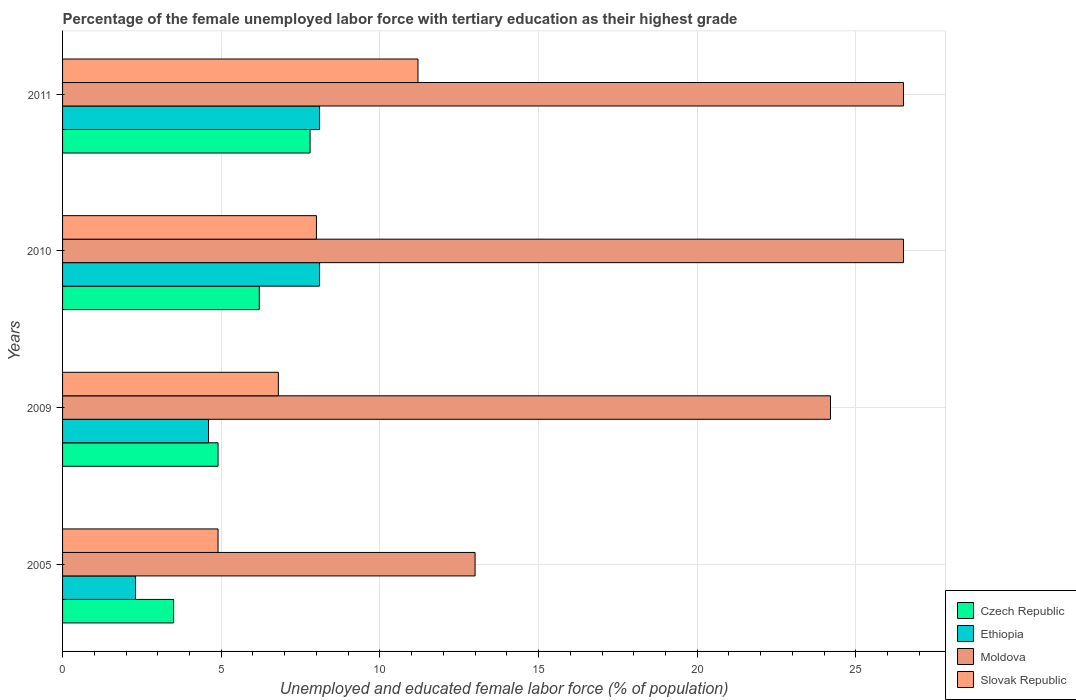How many different coloured bars are there?
Your answer should be compact. 4. Are the number of bars per tick equal to the number of legend labels?
Keep it short and to the point. Yes. How many bars are there on the 1st tick from the bottom?
Offer a very short reply. 4. What is the label of the 4th group of bars from the top?
Provide a succinct answer. 2005. In how many cases, is the number of bars for a given year not equal to the number of legend labels?
Your answer should be very brief. 0. What is the percentage of the unemployed female labor force with tertiary education in Czech Republic in 2009?
Your response must be concise. 4.9. Across all years, what is the maximum percentage of the unemployed female labor force with tertiary education in Slovak Republic?
Provide a short and direct response. 11.2. Across all years, what is the minimum percentage of the unemployed female labor force with tertiary education in Slovak Republic?
Your answer should be very brief. 4.9. In which year was the percentage of the unemployed female labor force with tertiary education in Slovak Republic maximum?
Your answer should be very brief. 2011. In which year was the percentage of the unemployed female labor force with tertiary education in Moldova minimum?
Keep it short and to the point. 2005. What is the total percentage of the unemployed female labor force with tertiary education in Ethiopia in the graph?
Offer a terse response. 23.1. What is the difference between the percentage of the unemployed female labor force with tertiary education in Slovak Republic in 2009 and that in 2010?
Offer a very short reply. -1.2. What is the difference between the percentage of the unemployed female labor force with tertiary education in Czech Republic in 2009 and the percentage of the unemployed female labor force with tertiary education in Slovak Republic in 2011?
Give a very brief answer. -6.3. What is the average percentage of the unemployed female labor force with tertiary education in Moldova per year?
Your answer should be compact. 22.55. In the year 2005, what is the difference between the percentage of the unemployed female labor force with tertiary education in Ethiopia and percentage of the unemployed female labor force with tertiary education in Czech Republic?
Your answer should be compact. -1.2. In how many years, is the percentage of the unemployed female labor force with tertiary education in Czech Republic greater than 21 %?
Your response must be concise. 0. What is the ratio of the percentage of the unemployed female labor force with tertiary education in Czech Republic in 2009 to that in 2010?
Make the answer very short. 0.79. Is the percentage of the unemployed female labor force with tertiary education in Moldova in 2009 less than that in 2011?
Your response must be concise. Yes. Is the difference between the percentage of the unemployed female labor force with tertiary education in Ethiopia in 2009 and 2011 greater than the difference between the percentage of the unemployed female labor force with tertiary education in Czech Republic in 2009 and 2011?
Offer a terse response. No. What is the difference between the highest and the second highest percentage of the unemployed female labor force with tertiary education in Slovak Republic?
Offer a terse response. 3.2. In how many years, is the percentage of the unemployed female labor force with tertiary education in Slovak Republic greater than the average percentage of the unemployed female labor force with tertiary education in Slovak Republic taken over all years?
Ensure brevity in your answer.  2. Is the sum of the percentage of the unemployed female labor force with tertiary education in Moldova in 2005 and 2010 greater than the maximum percentage of the unemployed female labor force with tertiary education in Czech Republic across all years?
Give a very brief answer. Yes. What does the 4th bar from the top in 2009 represents?
Provide a short and direct response. Czech Republic. What does the 3rd bar from the bottom in 2005 represents?
Make the answer very short. Moldova. Is it the case that in every year, the sum of the percentage of the unemployed female labor force with tertiary education in Czech Republic and percentage of the unemployed female labor force with tertiary education in Moldova is greater than the percentage of the unemployed female labor force with tertiary education in Ethiopia?
Keep it short and to the point. Yes. Are all the bars in the graph horizontal?
Ensure brevity in your answer.  Yes. How many years are there in the graph?
Keep it short and to the point. 4. What is the difference between two consecutive major ticks on the X-axis?
Your response must be concise. 5. Does the graph contain any zero values?
Provide a short and direct response. No. Where does the legend appear in the graph?
Give a very brief answer. Bottom right. How many legend labels are there?
Your response must be concise. 4. What is the title of the graph?
Give a very brief answer. Percentage of the female unemployed labor force with tertiary education as their highest grade. Does "Palau" appear as one of the legend labels in the graph?
Make the answer very short. No. What is the label or title of the X-axis?
Ensure brevity in your answer.  Unemployed and educated female labor force (% of population). What is the label or title of the Y-axis?
Your response must be concise. Years. What is the Unemployed and educated female labor force (% of population) of Czech Republic in 2005?
Provide a succinct answer. 3.5. What is the Unemployed and educated female labor force (% of population) in Ethiopia in 2005?
Your response must be concise. 2.3. What is the Unemployed and educated female labor force (% of population) of Slovak Republic in 2005?
Your answer should be very brief. 4.9. What is the Unemployed and educated female labor force (% of population) of Czech Republic in 2009?
Your answer should be very brief. 4.9. What is the Unemployed and educated female labor force (% of population) of Ethiopia in 2009?
Give a very brief answer. 4.6. What is the Unemployed and educated female labor force (% of population) of Moldova in 2009?
Provide a short and direct response. 24.2. What is the Unemployed and educated female labor force (% of population) in Slovak Republic in 2009?
Offer a terse response. 6.8. What is the Unemployed and educated female labor force (% of population) in Czech Republic in 2010?
Provide a short and direct response. 6.2. What is the Unemployed and educated female labor force (% of population) in Ethiopia in 2010?
Your answer should be compact. 8.1. What is the Unemployed and educated female labor force (% of population) in Moldova in 2010?
Provide a succinct answer. 26.5. What is the Unemployed and educated female labor force (% of population) of Slovak Republic in 2010?
Offer a very short reply. 8. What is the Unemployed and educated female labor force (% of population) in Czech Republic in 2011?
Your response must be concise. 7.8. What is the Unemployed and educated female labor force (% of population) of Ethiopia in 2011?
Make the answer very short. 8.1. What is the Unemployed and educated female labor force (% of population) in Moldova in 2011?
Ensure brevity in your answer.  26.5. What is the Unemployed and educated female labor force (% of population) in Slovak Republic in 2011?
Your answer should be compact. 11.2. Across all years, what is the maximum Unemployed and educated female labor force (% of population) of Czech Republic?
Provide a short and direct response. 7.8. Across all years, what is the maximum Unemployed and educated female labor force (% of population) of Ethiopia?
Keep it short and to the point. 8.1. Across all years, what is the maximum Unemployed and educated female labor force (% of population) of Slovak Republic?
Your response must be concise. 11.2. Across all years, what is the minimum Unemployed and educated female labor force (% of population) of Czech Republic?
Keep it short and to the point. 3.5. Across all years, what is the minimum Unemployed and educated female labor force (% of population) in Ethiopia?
Keep it short and to the point. 2.3. Across all years, what is the minimum Unemployed and educated female labor force (% of population) in Slovak Republic?
Ensure brevity in your answer.  4.9. What is the total Unemployed and educated female labor force (% of population) in Czech Republic in the graph?
Make the answer very short. 22.4. What is the total Unemployed and educated female labor force (% of population) in Ethiopia in the graph?
Make the answer very short. 23.1. What is the total Unemployed and educated female labor force (% of population) of Moldova in the graph?
Ensure brevity in your answer.  90.2. What is the total Unemployed and educated female labor force (% of population) of Slovak Republic in the graph?
Your response must be concise. 30.9. What is the difference between the Unemployed and educated female labor force (% of population) of Czech Republic in 2005 and that in 2009?
Offer a very short reply. -1.4. What is the difference between the Unemployed and educated female labor force (% of population) in Ethiopia in 2005 and that in 2009?
Your response must be concise. -2.3. What is the difference between the Unemployed and educated female labor force (% of population) in Slovak Republic in 2005 and that in 2009?
Your answer should be very brief. -1.9. What is the difference between the Unemployed and educated female labor force (% of population) of Slovak Republic in 2005 and that in 2010?
Make the answer very short. -3.1. What is the difference between the Unemployed and educated female labor force (% of population) of Czech Republic in 2005 and that in 2011?
Offer a terse response. -4.3. What is the difference between the Unemployed and educated female labor force (% of population) of Moldova in 2005 and that in 2011?
Keep it short and to the point. -13.5. What is the difference between the Unemployed and educated female labor force (% of population) of Slovak Republic in 2005 and that in 2011?
Your response must be concise. -6.3. What is the difference between the Unemployed and educated female labor force (% of population) of Czech Republic in 2009 and that in 2010?
Keep it short and to the point. -1.3. What is the difference between the Unemployed and educated female labor force (% of population) in Ethiopia in 2009 and that in 2010?
Offer a very short reply. -3.5. What is the difference between the Unemployed and educated female labor force (% of population) in Slovak Republic in 2009 and that in 2010?
Provide a short and direct response. -1.2. What is the difference between the Unemployed and educated female labor force (% of population) in Moldova in 2009 and that in 2011?
Offer a terse response. -2.3. What is the difference between the Unemployed and educated female labor force (% of population) of Ethiopia in 2010 and that in 2011?
Keep it short and to the point. 0. What is the difference between the Unemployed and educated female labor force (% of population) in Czech Republic in 2005 and the Unemployed and educated female labor force (% of population) in Ethiopia in 2009?
Ensure brevity in your answer.  -1.1. What is the difference between the Unemployed and educated female labor force (% of population) of Czech Republic in 2005 and the Unemployed and educated female labor force (% of population) of Moldova in 2009?
Your answer should be compact. -20.7. What is the difference between the Unemployed and educated female labor force (% of population) in Czech Republic in 2005 and the Unemployed and educated female labor force (% of population) in Slovak Republic in 2009?
Offer a very short reply. -3.3. What is the difference between the Unemployed and educated female labor force (% of population) in Ethiopia in 2005 and the Unemployed and educated female labor force (% of population) in Moldova in 2009?
Make the answer very short. -21.9. What is the difference between the Unemployed and educated female labor force (% of population) in Ethiopia in 2005 and the Unemployed and educated female labor force (% of population) in Slovak Republic in 2009?
Offer a terse response. -4.5. What is the difference between the Unemployed and educated female labor force (% of population) in Czech Republic in 2005 and the Unemployed and educated female labor force (% of population) in Ethiopia in 2010?
Offer a terse response. -4.6. What is the difference between the Unemployed and educated female labor force (% of population) of Czech Republic in 2005 and the Unemployed and educated female labor force (% of population) of Moldova in 2010?
Give a very brief answer. -23. What is the difference between the Unemployed and educated female labor force (% of population) of Czech Republic in 2005 and the Unemployed and educated female labor force (% of population) of Slovak Republic in 2010?
Your response must be concise. -4.5. What is the difference between the Unemployed and educated female labor force (% of population) of Ethiopia in 2005 and the Unemployed and educated female labor force (% of population) of Moldova in 2010?
Make the answer very short. -24.2. What is the difference between the Unemployed and educated female labor force (% of population) in Czech Republic in 2005 and the Unemployed and educated female labor force (% of population) in Ethiopia in 2011?
Give a very brief answer. -4.6. What is the difference between the Unemployed and educated female labor force (% of population) in Czech Republic in 2005 and the Unemployed and educated female labor force (% of population) in Moldova in 2011?
Your answer should be compact. -23. What is the difference between the Unemployed and educated female labor force (% of population) of Czech Republic in 2005 and the Unemployed and educated female labor force (% of population) of Slovak Republic in 2011?
Your answer should be very brief. -7.7. What is the difference between the Unemployed and educated female labor force (% of population) in Ethiopia in 2005 and the Unemployed and educated female labor force (% of population) in Moldova in 2011?
Your response must be concise. -24.2. What is the difference between the Unemployed and educated female labor force (% of population) in Moldova in 2005 and the Unemployed and educated female labor force (% of population) in Slovak Republic in 2011?
Keep it short and to the point. 1.8. What is the difference between the Unemployed and educated female labor force (% of population) of Czech Republic in 2009 and the Unemployed and educated female labor force (% of population) of Ethiopia in 2010?
Your answer should be very brief. -3.2. What is the difference between the Unemployed and educated female labor force (% of population) of Czech Republic in 2009 and the Unemployed and educated female labor force (% of population) of Moldova in 2010?
Offer a terse response. -21.6. What is the difference between the Unemployed and educated female labor force (% of population) of Ethiopia in 2009 and the Unemployed and educated female labor force (% of population) of Moldova in 2010?
Keep it short and to the point. -21.9. What is the difference between the Unemployed and educated female labor force (% of population) in Ethiopia in 2009 and the Unemployed and educated female labor force (% of population) in Slovak Republic in 2010?
Provide a short and direct response. -3.4. What is the difference between the Unemployed and educated female labor force (% of population) in Moldova in 2009 and the Unemployed and educated female labor force (% of population) in Slovak Republic in 2010?
Your answer should be very brief. 16.2. What is the difference between the Unemployed and educated female labor force (% of population) in Czech Republic in 2009 and the Unemployed and educated female labor force (% of population) in Moldova in 2011?
Offer a terse response. -21.6. What is the difference between the Unemployed and educated female labor force (% of population) of Czech Republic in 2009 and the Unemployed and educated female labor force (% of population) of Slovak Republic in 2011?
Offer a terse response. -6.3. What is the difference between the Unemployed and educated female labor force (% of population) in Ethiopia in 2009 and the Unemployed and educated female labor force (% of population) in Moldova in 2011?
Your answer should be compact. -21.9. What is the difference between the Unemployed and educated female labor force (% of population) of Czech Republic in 2010 and the Unemployed and educated female labor force (% of population) of Ethiopia in 2011?
Offer a very short reply. -1.9. What is the difference between the Unemployed and educated female labor force (% of population) in Czech Republic in 2010 and the Unemployed and educated female labor force (% of population) in Moldova in 2011?
Give a very brief answer. -20.3. What is the difference between the Unemployed and educated female labor force (% of population) of Czech Republic in 2010 and the Unemployed and educated female labor force (% of population) of Slovak Republic in 2011?
Ensure brevity in your answer.  -5. What is the difference between the Unemployed and educated female labor force (% of population) of Ethiopia in 2010 and the Unemployed and educated female labor force (% of population) of Moldova in 2011?
Your response must be concise. -18.4. What is the difference between the Unemployed and educated female labor force (% of population) in Ethiopia in 2010 and the Unemployed and educated female labor force (% of population) in Slovak Republic in 2011?
Your answer should be compact. -3.1. What is the average Unemployed and educated female labor force (% of population) in Ethiopia per year?
Offer a very short reply. 5.78. What is the average Unemployed and educated female labor force (% of population) in Moldova per year?
Your answer should be compact. 22.55. What is the average Unemployed and educated female labor force (% of population) of Slovak Republic per year?
Offer a very short reply. 7.72. In the year 2005, what is the difference between the Unemployed and educated female labor force (% of population) of Czech Republic and Unemployed and educated female labor force (% of population) of Ethiopia?
Your answer should be compact. 1.2. In the year 2005, what is the difference between the Unemployed and educated female labor force (% of population) of Czech Republic and Unemployed and educated female labor force (% of population) of Moldova?
Keep it short and to the point. -9.5. In the year 2005, what is the difference between the Unemployed and educated female labor force (% of population) of Czech Republic and Unemployed and educated female labor force (% of population) of Slovak Republic?
Provide a short and direct response. -1.4. In the year 2005, what is the difference between the Unemployed and educated female labor force (% of population) of Moldova and Unemployed and educated female labor force (% of population) of Slovak Republic?
Ensure brevity in your answer.  8.1. In the year 2009, what is the difference between the Unemployed and educated female labor force (% of population) in Czech Republic and Unemployed and educated female labor force (% of population) in Moldova?
Your answer should be compact. -19.3. In the year 2009, what is the difference between the Unemployed and educated female labor force (% of population) of Czech Republic and Unemployed and educated female labor force (% of population) of Slovak Republic?
Give a very brief answer. -1.9. In the year 2009, what is the difference between the Unemployed and educated female labor force (% of population) of Ethiopia and Unemployed and educated female labor force (% of population) of Moldova?
Your answer should be compact. -19.6. In the year 2009, what is the difference between the Unemployed and educated female labor force (% of population) in Ethiopia and Unemployed and educated female labor force (% of population) in Slovak Republic?
Your answer should be very brief. -2.2. In the year 2010, what is the difference between the Unemployed and educated female labor force (% of population) of Czech Republic and Unemployed and educated female labor force (% of population) of Ethiopia?
Offer a terse response. -1.9. In the year 2010, what is the difference between the Unemployed and educated female labor force (% of population) of Czech Republic and Unemployed and educated female labor force (% of population) of Moldova?
Your answer should be compact. -20.3. In the year 2010, what is the difference between the Unemployed and educated female labor force (% of population) of Ethiopia and Unemployed and educated female labor force (% of population) of Moldova?
Provide a succinct answer. -18.4. In the year 2010, what is the difference between the Unemployed and educated female labor force (% of population) in Ethiopia and Unemployed and educated female labor force (% of population) in Slovak Republic?
Provide a short and direct response. 0.1. In the year 2011, what is the difference between the Unemployed and educated female labor force (% of population) in Czech Republic and Unemployed and educated female labor force (% of population) in Moldova?
Keep it short and to the point. -18.7. In the year 2011, what is the difference between the Unemployed and educated female labor force (% of population) of Czech Republic and Unemployed and educated female labor force (% of population) of Slovak Republic?
Offer a terse response. -3.4. In the year 2011, what is the difference between the Unemployed and educated female labor force (% of population) in Ethiopia and Unemployed and educated female labor force (% of population) in Moldova?
Provide a short and direct response. -18.4. In the year 2011, what is the difference between the Unemployed and educated female labor force (% of population) in Ethiopia and Unemployed and educated female labor force (% of population) in Slovak Republic?
Your response must be concise. -3.1. In the year 2011, what is the difference between the Unemployed and educated female labor force (% of population) of Moldova and Unemployed and educated female labor force (% of population) of Slovak Republic?
Your answer should be very brief. 15.3. What is the ratio of the Unemployed and educated female labor force (% of population) in Moldova in 2005 to that in 2009?
Make the answer very short. 0.54. What is the ratio of the Unemployed and educated female labor force (% of population) of Slovak Republic in 2005 to that in 2009?
Keep it short and to the point. 0.72. What is the ratio of the Unemployed and educated female labor force (% of population) of Czech Republic in 2005 to that in 2010?
Offer a terse response. 0.56. What is the ratio of the Unemployed and educated female labor force (% of population) of Ethiopia in 2005 to that in 2010?
Your response must be concise. 0.28. What is the ratio of the Unemployed and educated female labor force (% of population) of Moldova in 2005 to that in 2010?
Provide a succinct answer. 0.49. What is the ratio of the Unemployed and educated female labor force (% of population) in Slovak Republic in 2005 to that in 2010?
Your answer should be compact. 0.61. What is the ratio of the Unemployed and educated female labor force (% of population) in Czech Republic in 2005 to that in 2011?
Provide a succinct answer. 0.45. What is the ratio of the Unemployed and educated female labor force (% of population) of Ethiopia in 2005 to that in 2011?
Give a very brief answer. 0.28. What is the ratio of the Unemployed and educated female labor force (% of population) in Moldova in 2005 to that in 2011?
Offer a terse response. 0.49. What is the ratio of the Unemployed and educated female labor force (% of population) in Slovak Republic in 2005 to that in 2011?
Make the answer very short. 0.44. What is the ratio of the Unemployed and educated female labor force (% of population) of Czech Republic in 2009 to that in 2010?
Make the answer very short. 0.79. What is the ratio of the Unemployed and educated female labor force (% of population) in Ethiopia in 2009 to that in 2010?
Ensure brevity in your answer.  0.57. What is the ratio of the Unemployed and educated female labor force (% of population) in Moldova in 2009 to that in 2010?
Offer a very short reply. 0.91. What is the ratio of the Unemployed and educated female labor force (% of population) in Czech Republic in 2009 to that in 2011?
Give a very brief answer. 0.63. What is the ratio of the Unemployed and educated female labor force (% of population) in Ethiopia in 2009 to that in 2011?
Make the answer very short. 0.57. What is the ratio of the Unemployed and educated female labor force (% of population) of Moldova in 2009 to that in 2011?
Your answer should be very brief. 0.91. What is the ratio of the Unemployed and educated female labor force (% of population) of Slovak Republic in 2009 to that in 2011?
Your answer should be compact. 0.61. What is the ratio of the Unemployed and educated female labor force (% of population) of Czech Republic in 2010 to that in 2011?
Give a very brief answer. 0.79. What is the ratio of the Unemployed and educated female labor force (% of population) of Slovak Republic in 2010 to that in 2011?
Ensure brevity in your answer.  0.71. What is the difference between the highest and the second highest Unemployed and educated female labor force (% of population) in Czech Republic?
Ensure brevity in your answer.  1.6. What is the difference between the highest and the lowest Unemployed and educated female labor force (% of population) in Ethiopia?
Offer a terse response. 5.8. 